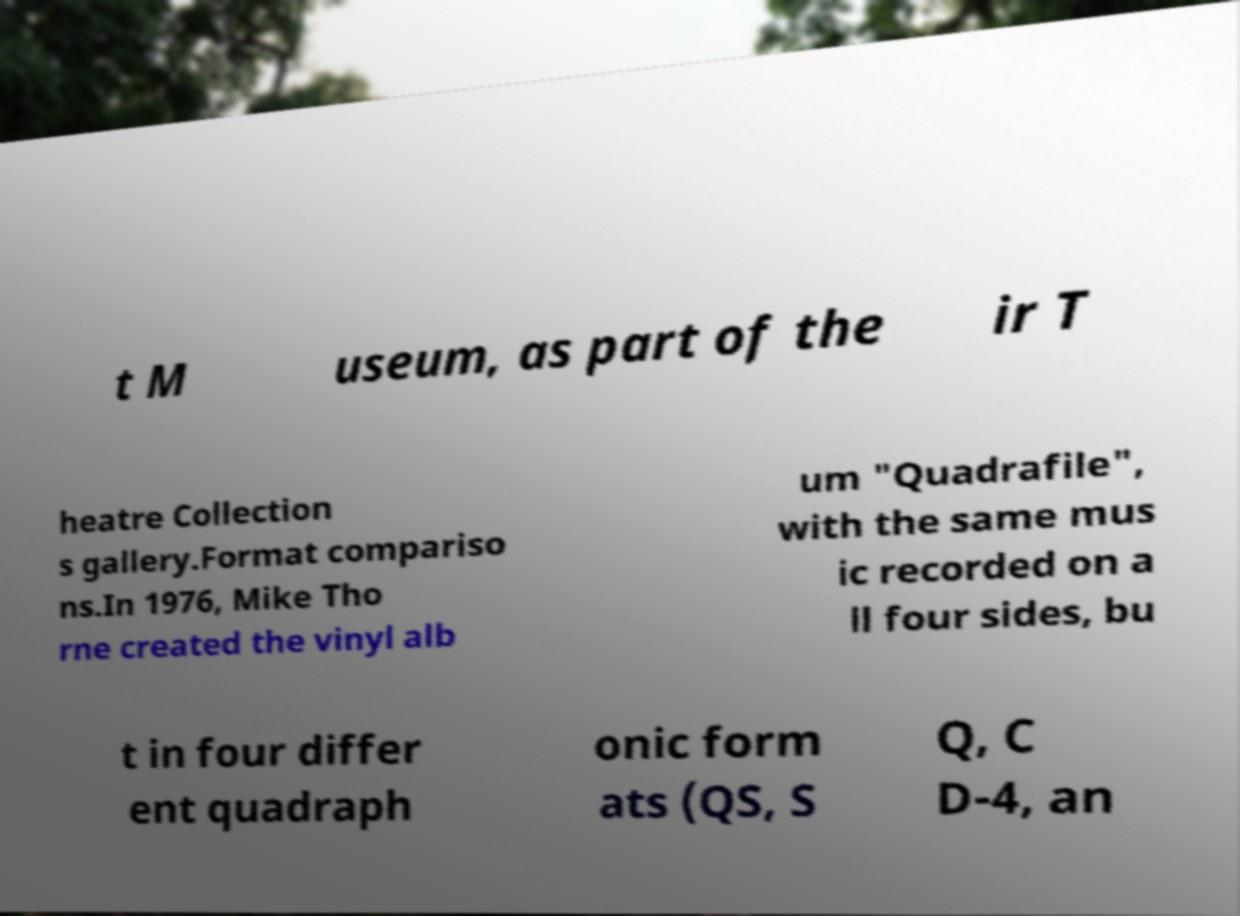I need the written content from this picture converted into text. Can you do that? t M useum, as part of the ir T heatre Collection s gallery.Format compariso ns.In 1976, Mike Tho rne created the vinyl alb um "Quadrafile", with the same mus ic recorded on a ll four sides, bu t in four differ ent quadraph onic form ats (QS, S Q, C D-4, an 